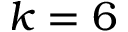<formula> <loc_0><loc_0><loc_500><loc_500>k = 6</formula> 